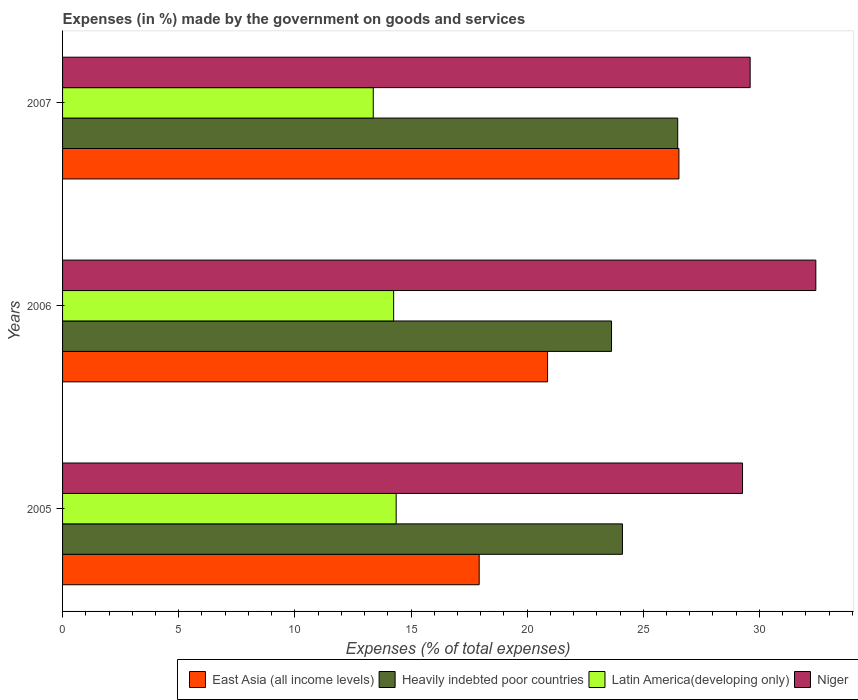How many different coloured bars are there?
Your answer should be compact. 4. How many groups of bars are there?
Give a very brief answer. 3. Are the number of bars per tick equal to the number of legend labels?
Offer a terse response. Yes. How many bars are there on the 1st tick from the bottom?
Ensure brevity in your answer.  4. What is the label of the 2nd group of bars from the top?
Keep it short and to the point. 2006. What is the percentage of expenses made by the government on goods and services in East Asia (all income levels) in 2007?
Offer a very short reply. 26.53. Across all years, what is the maximum percentage of expenses made by the government on goods and services in Heavily indebted poor countries?
Your answer should be compact. 26.48. Across all years, what is the minimum percentage of expenses made by the government on goods and services in Niger?
Keep it short and to the point. 29.27. What is the total percentage of expenses made by the government on goods and services in Heavily indebted poor countries in the graph?
Keep it short and to the point. 74.22. What is the difference between the percentage of expenses made by the government on goods and services in East Asia (all income levels) in 2005 and that in 2007?
Provide a short and direct response. -8.6. What is the difference between the percentage of expenses made by the government on goods and services in East Asia (all income levels) in 2006 and the percentage of expenses made by the government on goods and services in Latin America(developing only) in 2005?
Offer a very short reply. 6.52. What is the average percentage of expenses made by the government on goods and services in Heavily indebted poor countries per year?
Give a very brief answer. 24.74. In the year 2005, what is the difference between the percentage of expenses made by the government on goods and services in Niger and percentage of expenses made by the government on goods and services in Heavily indebted poor countries?
Offer a very short reply. 5.17. In how many years, is the percentage of expenses made by the government on goods and services in Heavily indebted poor countries greater than 8 %?
Offer a terse response. 3. What is the ratio of the percentage of expenses made by the government on goods and services in East Asia (all income levels) in 2005 to that in 2007?
Your answer should be compact. 0.68. Is the percentage of expenses made by the government on goods and services in Latin America(developing only) in 2005 less than that in 2006?
Your response must be concise. No. Is the difference between the percentage of expenses made by the government on goods and services in Niger in 2006 and 2007 greater than the difference between the percentage of expenses made by the government on goods and services in Heavily indebted poor countries in 2006 and 2007?
Keep it short and to the point. Yes. What is the difference between the highest and the second highest percentage of expenses made by the government on goods and services in East Asia (all income levels)?
Give a very brief answer. 5.65. What is the difference between the highest and the lowest percentage of expenses made by the government on goods and services in Heavily indebted poor countries?
Offer a terse response. 2.85. Is the sum of the percentage of expenses made by the government on goods and services in Latin America(developing only) in 2005 and 2006 greater than the maximum percentage of expenses made by the government on goods and services in Heavily indebted poor countries across all years?
Your response must be concise. Yes. Is it the case that in every year, the sum of the percentage of expenses made by the government on goods and services in Heavily indebted poor countries and percentage of expenses made by the government on goods and services in East Asia (all income levels) is greater than the sum of percentage of expenses made by the government on goods and services in Niger and percentage of expenses made by the government on goods and services in Latin America(developing only)?
Keep it short and to the point. No. What does the 1st bar from the top in 2007 represents?
Keep it short and to the point. Niger. What does the 3rd bar from the bottom in 2007 represents?
Give a very brief answer. Latin America(developing only). What is the difference between two consecutive major ticks on the X-axis?
Your response must be concise. 5. Are the values on the major ticks of X-axis written in scientific E-notation?
Provide a succinct answer. No. Does the graph contain any zero values?
Offer a very short reply. No. Where does the legend appear in the graph?
Your answer should be very brief. Bottom right. How are the legend labels stacked?
Ensure brevity in your answer.  Horizontal. What is the title of the graph?
Your answer should be very brief. Expenses (in %) made by the government on goods and services. What is the label or title of the X-axis?
Provide a succinct answer. Expenses (% of total expenses). What is the Expenses (% of total expenses) of East Asia (all income levels) in 2005?
Your answer should be compact. 17.94. What is the Expenses (% of total expenses) in Heavily indebted poor countries in 2005?
Provide a short and direct response. 24.1. What is the Expenses (% of total expenses) in Latin America(developing only) in 2005?
Provide a succinct answer. 14.36. What is the Expenses (% of total expenses) in Niger in 2005?
Provide a succinct answer. 29.27. What is the Expenses (% of total expenses) of East Asia (all income levels) in 2006?
Offer a very short reply. 20.88. What is the Expenses (% of total expenses) of Heavily indebted poor countries in 2006?
Offer a terse response. 23.63. What is the Expenses (% of total expenses) in Latin America(developing only) in 2006?
Ensure brevity in your answer.  14.25. What is the Expenses (% of total expenses) of Niger in 2006?
Provide a short and direct response. 32.43. What is the Expenses (% of total expenses) of East Asia (all income levels) in 2007?
Provide a short and direct response. 26.53. What is the Expenses (% of total expenses) of Heavily indebted poor countries in 2007?
Give a very brief answer. 26.48. What is the Expenses (% of total expenses) of Latin America(developing only) in 2007?
Make the answer very short. 13.38. What is the Expenses (% of total expenses) in Niger in 2007?
Offer a terse response. 29.6. Across all years, what is the maximum Expenses (% of total expenses) in East Asia (all income levels)?
Your answer should be very brief. 26.53. Across all years, what is the maximum Expenses (% of total expenses) in Heavily indebted poor countries?
Provide a succinct answer. 26.48. Across all years, what is the maximum Expenses (% of total expenses) in Latin America(developing only)?
Your answer should be compact. 14.36. Across all years, what is the maximum Expenses (% of total expenses) in Niger?
Provide a short and direct response. 32.43. Across all years, what is the minimum Expenses (% of total expenses) in East Asia (all income levels)?
Ensure brevity in your answer.  17.94. Across all years, what is the minimum Expenses (% of total expenses) in Heavily indebted poor countries?
Keep it short and to the point. 23.63. Across all years, what is the minimum Expenses (% of total expenses) of Latin America(developing only)?
Give a very brief answer. 13.38. Across all years, what is the minimum Expenses (% of total expenses) in Niger?
Your answer should be compact. 29.27. What is the total Expenses (% of total expenses) of East Asia (all income levels) in the graph?
Offer a very short reply. 65.35. What is the total Expenses (% of total expenses) in Heavily indebted poor countries in the graph?
Keep it short and to the point. 74.22. What is the total Expenses (% of total expenses) of Latin America(developing only) in the graph?
Give a very brief answer. 41.99. What is the total Expenses (% of total expenses) of Niger in the graph?
Make the answer very short. 91.3. What is the difference between the Expenses (% of total expenses) in East Asia (all income levels) in 2005 and that in 2006?
Offer a very short reply. -2.94. What is the difference between the Expenses (% of total expenses) in Heavily indebted poor countries in 2005 and that in 2006?
Offer a terse response. 0.47. What is the difference between the Expenses (% of total expenses) of Latin America(developing only) in 2005 and that in 2006?
Make the answer very short. 0.11. What is the difference between the Expenses (% of total expenses) of Niger in 2005 and that in 2006?
Make the answer very short. -3.16. What is the difference between the Expenses (% of total expenses) of East Asia (all income levels) in 2005 and that in 2007?
Give a very brief answer. -8.6. What is the difference between the Expenses (% of total expenses) in Heavily indebted poor countries in 2005 and that in 2007?
Give a very brief answer. -2.38. What is the difference between the Expenses (% of total expenses) of Latin America(developing only) in 2005 and that in 2007?
Your response must be concise. 0.99. What is the difference between the Expenses (% of total expenses) in Niger in 2005 and that in 2007?
Offer a very short reply. -0.33. What is the difference between the Expenses (% of total expenses) of East Asia (all income levels) in 2006 and that in 2007?
Ensure brevity in your answer.  -5.65. What is the difference between the Expenses (% of total expenses) of Heavily indebted poor countries in 2006 and that in 2007?
Provide a succinct answer. -2.85. What is the difference between the Expenses (% of total expenses) of Latin America(developing only) in 2006 and that in 2007?
Make the answer very short. 0.88. What is the difference between the Expenses (% of total expenses) in Niger in 2006 and that in 2007?
Offer a terse response. 2.83. What is the difference between the Expenses (% of total expenses) of East Asia (all income levels) in 2005 and the Expenses (% of total expenses) of Heavily indebted poor countries in 2006?
Your answer should be very brief. -5.7. What is the difference between the Expenses (% of total expenses) in East Asia (all income levels) in 2005 and the Expenses (% of total expenses) in Latin America(developing only) in 2006?
Your response must be concise. 3.68. What is the difference between the Expenses (% of total expenses) of East Asia (all income levels) in 2005 and the Expenses (% of total expenses) of Niger in 2006?
Keep it short and to the point. -14.49. What is the difference between the Expenses (% of total expenses) of Heavily indebted poor countries in 2005 and the Expenses (% of total expenses) of Latin America(developing only) in 2006?
Provide a short and direct response. 9.85. What is the difference between the Expenses (% of total expenses) of Heavily indebted poor countries in 2005 and the Expenses (% of total expenses) of Niger in 2006?
Offer a very short reply. -8.32. What is the difference between the Expenses (% of total expenses) of Latin America(developing only) in 2005 and the Expenses (% of total expenses) of Niger in 2006?
Keep it short and to the point. -18.07. What is the difference between the Expenses (% of total expenses) of East Asia (all income levels) in 2005 and the Expenses (% of total expenses) of Heavily indebted poor countries in 2007?
Your response must be concise. -8.55. What is the difference between the Expenses (% of total expenses) of East Asia (all income levels) in 2005 and the Expenses (% of total expenses) of Latin America(developing only) in 2007?
Provide a short and direct response. 4.56. What is the difference between the Expenses (% of total expenses) in East Asia (all income levels) in 2005 and the Expenses (% of total expenses) in Niger in 2007?
Make the answer very short. -11.67. What is the difference between the Expenses (% of total expenses) in Heavily indebted poor countries in 2005 and the Expenses (% of total expenses) in Latin America(developing only) in 2007?
Your response must be concise. 10.73. What is the difference between the Expenses (% of total expenses) in Heavily indebted poor countries in 2005 and the Expenses (% of total expenses) in Niger in 2007?
Your response must be concise. -5.5. What is the difference between the Expenses (% of total expenses) in Latin America(developing only) in 2005 and the Expenses (% of total expenses) in Niger in 2007?
Make the answer very short. -15.24. What is the difference between the Expenses (% of total expenses) in East Asia (all income levels) in 2006 and the Expenses (% of total expenses) in Heavily indebted poor countries in 2007?
Provide a succinct answer. -5.6. What is the difference between the Expenses (% of total expenses) in East Asia (all income levels) in 2006 and the Expenses (% of total expenses) in Latin America(developing only) in 2007?
Your response must be concise. 7.5. What is the difference between the Expenses (% of total expenses) in East Asia (all income levels) in 2006 and the Expenses (% of total expenses) in Niger in 2007?
Provide a short and direct response. -8.72. What is the difference between the Expenses (% of total expenses) of Heavily indebted poor countries in 2006 and the Expenses (% of total expenses) of Latin America(developing only) in 2007?
Offer a terse response. 10.26. What is the difference between the Expenses (% of total expenses) in Heavily indebted poor countries in 2006 and the Expenses (% of total expenses) in Niger in 2007?
Your answer should be compact. -5.97. What is the difference between the Expenses (% of total expenses) in Latin America(developing only) in 2006 and the Expenses (% of total expenses) in Niger in 2007?
Keep it short and to the point. -15.35. What is the average Expenses (% of total expenses) in East Asia (all income levels) per year?
Offer a terse response. 21.78. What is the average Expenses (% of total expenses) in Heavily indebted poor countries per year?
Make the answer very short. 24.74. What is the average Expenses (% of total expenses) in Latin America(developing only) per year?
Keep it short and to the point. 14. What is the average Expenses (% of total expenses) in Niger per year?
Your answer should be very brief. 30.43. In the year 2005, what is the difference between the Expenses (% of total expenses) in East Asia (all income levels) and Expenses (% of total expenses) in Heavily indebted poor countries?
Keep it short and to the point. -6.17. In the year 2005, what is the difference between the Expenses (% of total expenses) in East Asia (all income levels) and Expenses (% of total expenses) in Latin America(developing only)?
Offer a terse response. 3.57. In the year 2005, what is the difference between the Expenses (% of total expenses) in East Asia (all income levels) and Expenses (% of total expenses) in Niger?
Ensure brevity in your answer.  -11.34. In the year 2005, what is the difference between the Expenses (% of total expenses) of Heavily indebted poor countries and Expenses (% of total expenses) of Latin America(developing only)?
Provide a short and direct response. 9.74. In the year 2005, what is the difference between the Expenses (% of total expenses) of Heavily indebted poor countries and Expenses (% of total expenses) of Niger?
Give a very brief answer. -5.17. In the year 2005, what is the difference between the Expenses (% of total expenses) in Latin America(developing only) and Expenses (% of total expenses) in Niger?
Make the answer very short. -14.91. In the year 2006, what is the difference between the Expenses (% of total expenses) of East Asia (all income levels) and Expenses (% of total expenses) of Heavily indebted poor countries?
Make the answer very short. -2.75. In the year 2006, what is the difference between the Expenses (% of total expenses) in East Asia (all income levels) and Expenses (% of total expenses) in Latin America(developing only)?
Offer a very short reply. 6.63. In the year 2006, what is the difference between the Expenses (% of total expenses) in East Asia (all income levels) and Expenses (% of total expenses) in Niger?
Your answer should be very brief. -11.55. In the year 2006, what is the difference between the Expenses (% of total expenses) in Heavily indebted poor countries and Expenses (% of total expenses) in Latin America(developing only)?
Keep it short and to the point. 9.38. In the year 2006, what is the difference between the Expenses (% of total expenses) of Heavily indebted poor countries and Expenses (% of total expenses) of Niger?
Your answer should be compact. -8.79. In the year 2006, what is the difference between the Expenses (% of total expenses) of Latin America(developing only) and Expenses (% of total expenses) of Niger?
Keep it short and to the point. -18.17. In the year 2007, what is the difference between the Expenses (% of total expenses) of East Asia (all income levels) and Expenses (% of total expenses) of Heavily indebted poor countries?
Give a very brief answer. 0.05. In the year 2007, what is the difference between the Expenses (% of total expenses) of East Asia (all income levels) and Expenses (% of total expenses) of Latin America(developing only)?
Ensure brevity in your answer.  13.16. In the year 2007, what is the difference between the Expenses (% of total expenses) of East Asia (all income levels) and Expenses (% of total expenses) of Niger?
Give a very brief answer. -3.07. In the year 2007, what is the difference between the Expenses (% of total expenses) in Heavily indebted poor countries and Expenses (% of total expenses) in Latin America(developing only)?
Make the answer very short. 13.11. In the year 2007, what is the difference between the Expenses (% of total expenses) of Heavily indebted poor countries and Expenses (% of total expenses) of Niger?
Your answer should be compact. -3.12. In the year 2007, what is the difference between the Expenses (% of total expenses) of Latin America(developing only) and Expenses (% of total expenses) of Niger?
Provide a short and direct response. -16.23. What is the ratio of the Expenses (% of total expenses) in East Asia (all income levels) in 2005 to that in 2006?
Your answer should be compact. 0.86. What is the ratio of the Expenses (% of total expenses) of Heavily indebted poor countries in 2005 to that in 2006?
Provide a short and direct response. 1.02. What is the ratio of the Expenses (% of total expenses) in Latin America(developing only) in 2005 to that in 2006?
Provide a short and direct response. 1.01. What is the ratio of the Expenses (% of total expenses) in Niger in 2005 to that in 2006?
Give a very brief answer. 0.9. What is the ratio of the Expenses (% of total expenses) of East Asia (all income levels) in 2005 to that in 2007?
Provide a short and direct response. 0.68. What is the ratio of the Expenses (% of total expenses) in Heavily indebted poor countries in 2005 to that in 2007?
Your response must be concise. 0.91. What is the ratio of the Expenses (% of total expenses) in Latin America(developing only) in 2005 to that in 2007?
Offer a terse response. 1.07. What is the ratio of the Expenses (% of total expenses) of Niger in 2005 to that in 2007?
Provide a succinct answer. 0.99. What is the ratio of the Expenses (% of total expenses) of East Asia (all income levels) in 2006 to that in 2007?
Your answer should be very brief. 0.79. What is the ratio of the Expenses (% of total expenses) of Heavily indebted poor countries in 2006 to that in 2007?
Give a very brief answer. 0.89. What is the ratio of the Expenses (% of total expenses) in Latin America(developing only) in 2006 to that in 2007?
Keep it short and to the point. 1.07. What is the ratio of the Expenses (% of total expenses) in Niger in 2006 to that in 2007?
Your answer should be compact. 1.1. What is the difference between the highest and the second highest Expenses (% of total expenses) of East Asia (all income levels)?
Give a very brief answer. 5.65. What is the difference between the highest and the second highest Expenses (% of total expenses) of Heavily indebted poor countries?
Provide a succinct answer. 2.38. What is the difference between the highest and the second highest Expenses (% of total expenses) in Latin America(developing only)?
Keep it short and to the point. 0.11. What is the difference between the highest and the second highest Expenses (% of total expenses) in Niger?
Offer a terse response. 2.83. What is the difference between the highest and the lowest Expenses (% of total expenses) of East Asia (all income levels)?
Offer a very short reply. 8.6. What is the difference between the highest and the lowest Expenses (% of total expenses) of Heavily indebted poor countries?
Your answer should be very brief. 2.85. What is the difference between the highest and the lowest Expenses (% of total expenses) in Latin America(developing only)?
Ensure brevity in your answer.  0.99. What is the difference between the highest and the lowest Expenses (% of total expenses) in Niger?
Your answer should be compact. 3.16. 